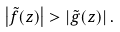<formula> <loc_0><loc_0><loc_500><loc_500>\left | \tilde { f } ( z ) \right | > \left | \tilde { g } ( z ) \right | .</formula> 